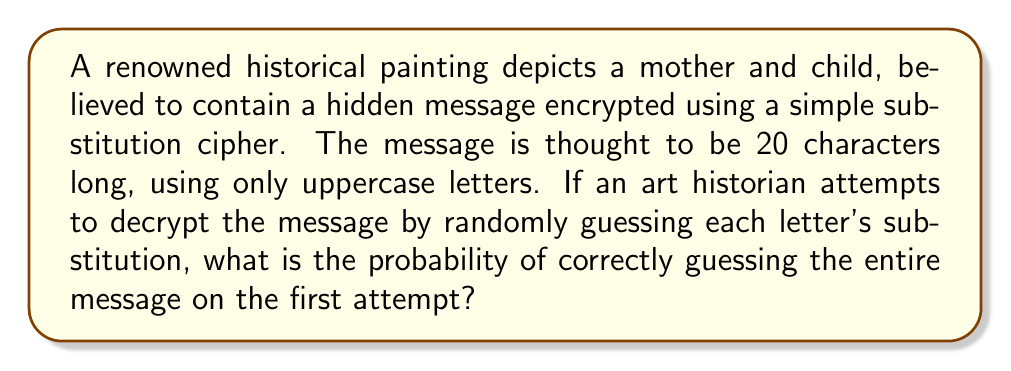Provide a solution to this math problem. Let's approach this step-by-step:

1) In a simple substitution cipher, each letter is replaced by another letter consistently throughout the message.

2) There are 26 letters in the English alphabet.

3) For the first letter, we have 26 choices.

4) For each subsequent letter, we have one less choice, as each letter can only be used once in the substitution.

5) Therefore, the total number of possible substitutions is:

   $$26 \times 25 \times 24 \times ... \times 7 = 26!$$

6) The probability of guessing the correct substitution is the reciprocal of this number:

   $$P(\text{correct guess}) = \frac{1}{26!}$$

7) We can calculate this using a calculator or computer:

   $$\frac{1}{26!} \approx 4.0329 \times 10^{-27}$$

This extremely small probability reflects the strength of even a simple substitution cipher when applied to the entire alphabet.
Answer: $\frac{1}{26!}$ or approximately $4.0329 \times 10^{-27}$ 